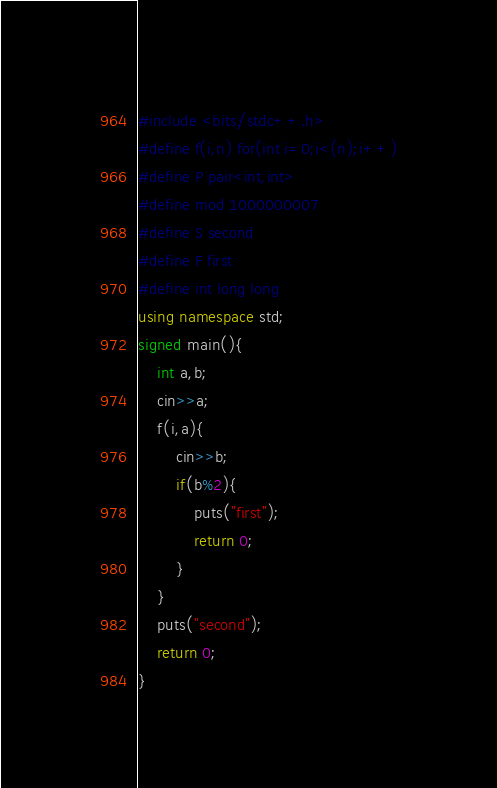<code> <loc_0><loc_0><loc_500><loc_500><_C++_>#include <bits/stdc++.h>
#define f(i,n) for(int i=0;i<(n);i++)
#define P pair<int,int>
#define mod 1000000007
#define S second
#define F first
#define int long long
using namespace std;
signed main(){
	int a,b;
	cin>>a;
	f(i,a){
		cin>>b;
		if(b%2){
			puts("first");
			return 0;
		}
	}
	puts("second");
	return 0;
}
</code> 